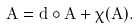<formula> <loc_0><loc_0><loc_500><loc_500>A = d \circ \tilde { A } + \chi ( A ) .</formula> 